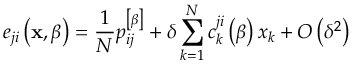Convert formula to latex. <formula><loc_0><loc_0><loc_500><loc_500>e _ { j i } \left ( x , \beta \right ) = \frac { 1 } { N } p _ { i j } ^ { \left [ \beta \right ] } + \delta \sum _ { k = 1 } ^ { N } c _ { k } ^ { j i } \left ( \beta \right ) x _ { k } + O \left ( \delta ^ { 2 } \right )</formula> 